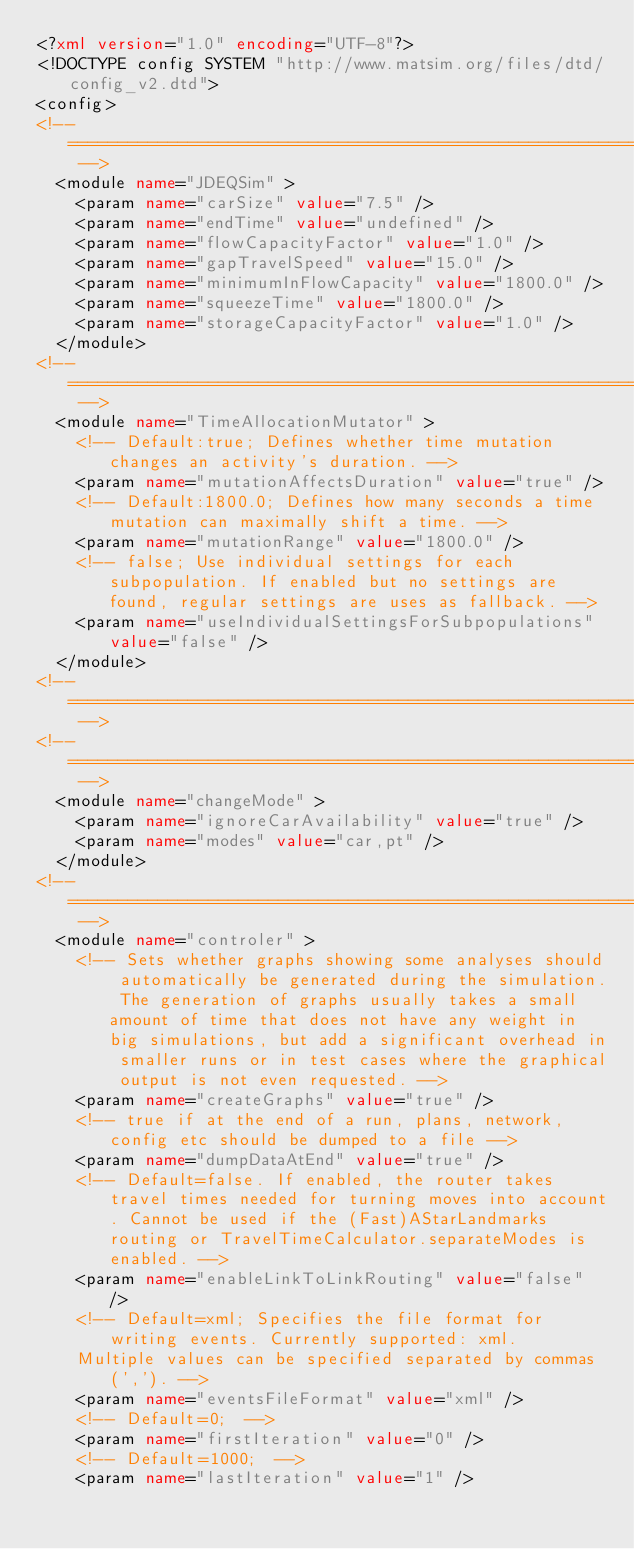Convert code to text. <code><loc_0><loc_0><loc_500><loc_500><_XML_><?xml version="1.0" encoding="UTF-8"?>
<!DOCTYPE config SYSTEM "http://www.matsim.org/files/dtd/config_v2.dtd">
<config>
<!-- ====================================================================== -->
	<module name="JDEQSim" >
		<param name="carSize" value="7.5" />
		<param name="endTime" value="undefined" />
		<param name="flowCapacityFactor" value="1.0" />
		<param name="gapTravelSpeed" value="15.0" />
		<param name="minimumInFlowCapacity" value="1800.0" />
		<param name="squeezeTime" value="1800.0" />
		<param name="storageCapacityFactor" value="1.0" />
	</module>
<!-- ====================================================================== -->
	<module name="TimeAllocationMutator" >
		<!-- Default:true; Defines whether time mutation changes an activity's duration. -->
		<param name="mutationAffectsDuration" value="true" />
		<!-- Default:1800.0; Defines how many seconds a time mutation can maximally shift a time. -->
		<param name="mutationRange" value="1800.0" />
		<!-- false; Use individual settings for each subpopulation. If enabled but no settings are found, regular settings are uses as fallback. -->
		<param name="useIndividualSettingsForSubpopulations" value="false" />
	</module>
<!-- ====================================================================== -->
<!-- ====================================================================== -->
	<module name="changeMode" >
		<param name="ignoreCarAvailability" value="true" />
		<param name="modes" value="car,pt" />
	</module>
<!-- ====================================================================== -->
	<module name="controler" >
		<!-- Sets whether graphs showing some analyses should automatically be generated during the simulation. The generation of graphs usually takes a small amount of time that does not have any weight in big simulations, but add a significant overhead in smaller runs or in test cases where the graphical output is not even requested. -->
		<param name="createGraphs" value="true" />
		<!-- true if at the end of a run, plans, network, config etc should be dumped to a file -->
		<param name="dumpDataAtEnd" value="true" />
		<!-- Default=false. If enabled, the router takes travel times needed for turning moves into account. Cannot be used if the (Fast)AStarLandmarks routing or TravelTimeCalculator.separateModes is enabled. -->
		<param name="enableLinkToLinkRouting" value="false" />
		<!-- Default=xml; Specifies the file format for writing events. Currently supported: xml.
		Multiple values can be specified separated by commas (','). -->
		<param name="eventsFileFormat" value="xml" />
		<!-- Default=0;  -->
		<param name="firstIteration" value="0" />
		<!-- Default=1000;  -->
		<param name="lastIteration" value="1" /></code> 